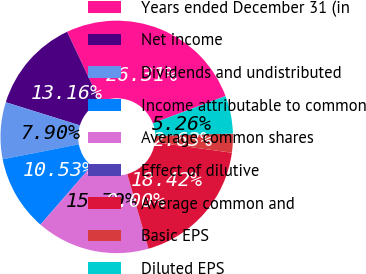Convert chart. <chart><loc_0><loc_0><loc_500><loc_500><pie_chart><fcel>Years ended December 31 (in<fcel>Net income<fcel>Dividends and undistributed<fcel>Income attributable to common<fcel>Average common shares<fcel>Effect of dilutive<fcel>Average common and<fcel>Basic EPS<fcel>Diluted EPS<nl><fcel>26.31%<fcel>13.16%<fcel>7.9%<fcel>10.53%<fcel>15.79%<fcel>0.0%<fcel>18.42%<fcel>2.63%<fcel>5.26%<nl></chart> 